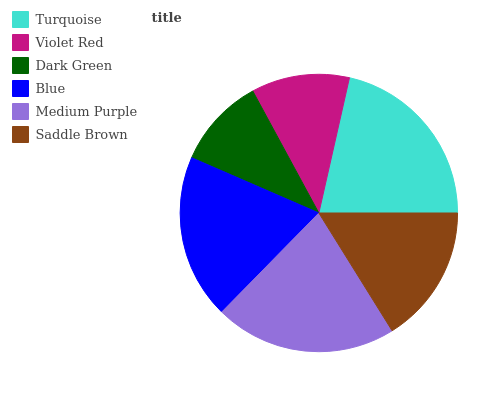Is Dark Green the minimum?
Answer yes or no. Yes. Is Turquoise the maximum?
Answer yes or no. Yes. Is Violet Red the minimum?
Answer yes or no. No. Is Violet Red the maximum?
Answer yes or no. No. Is Turquoise greater than Violet Red?
Answer yes or no. Yes. Is Violet Red less than Turquoise?
Answer yes or no. Yes. Is Violet Red greater than Turquoise?
Answer yes or no. No. Is Turquoise less than Violet Red?
Answer yes or no. No. Is Blue the high median?
Answer yes or no. Yes. Is Saddle Brown the low median?
Answer yes or no. Yes. Is Saddle Brown the high median?
Answer yes or no. No. Is Turquoise the low median?
Answer yes or no. No. 